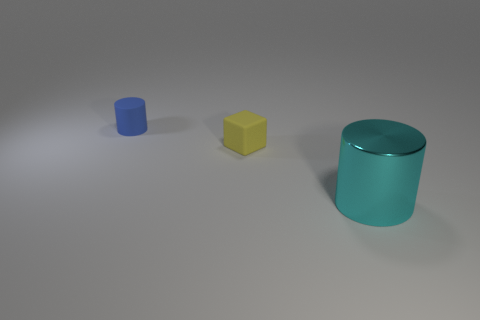Is there anything else that is made of the same material as the big cyan cylinder?
Keep it short and to the point. No. There is a big object; what number of big cyan cylinders are right of it?
Keep it short and to the point. 0. The rubber object that is the same shape as the large cyan shiny thing is what size?
Give a very brief answer. Small. What is the size of the object that is both right of the blue cylinder and left of the large cyan shiny cylinder?
Offer a very short reply. Small. There is a big shiny thing; is it the same color as the cylinder that is on the left side of the big cyan cylinder?
Offer a terse response. No. How many cyan things are either large cylinders or small matte cubes?
Your answer should be very brief. 1. There is a yellow thing; what shape is it?
Your answer should be compact. Cube. What number of other objects are the same shape as the big cyan shiny object?
Keep it short and to the point. 1. What color is the block that is right of the matte cylinder?
Provide a short and direct response. Yellow. Is the material of the cyan cylinder the same as the blue cylinder?
Offer a terse response. No. 